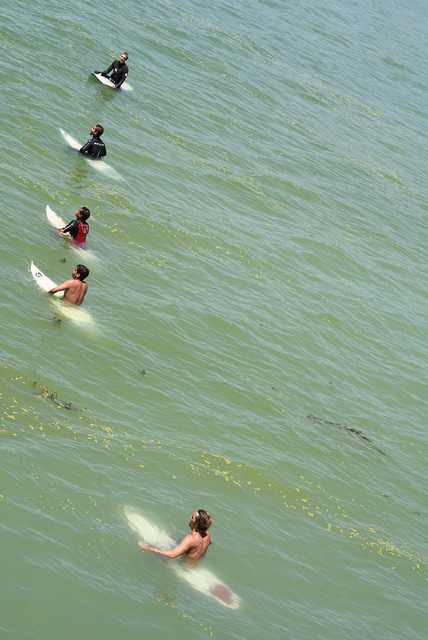Do all the surfers have their upper torso covered? No, not all surfers have their upper torso covered. While some may be wearing wetsuits or rash guards, at least one surfer is without upper body coverage, enjoying the freedom and the sun. 